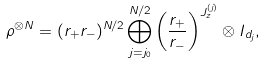<formula> <loc_0><loc_0><loc_500><loc_500>\rho ^ { \otimes N } = ( r _ { + } r _ { - } ) ^ { N / 2 } \bigoplus _ { j = j _ { 0 } } ^ { N / 2 } \left ( \frac { r _ { + } } { r _ { - } } \right ) ^ { J _ { z } ^ { ( j ) } } \otimes I _ { d _ { j } } ,</formula> 